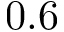Convert formula to latex. <formula><loc_0><loc_0><loc_500><loc_500>0 . 6</formula> 